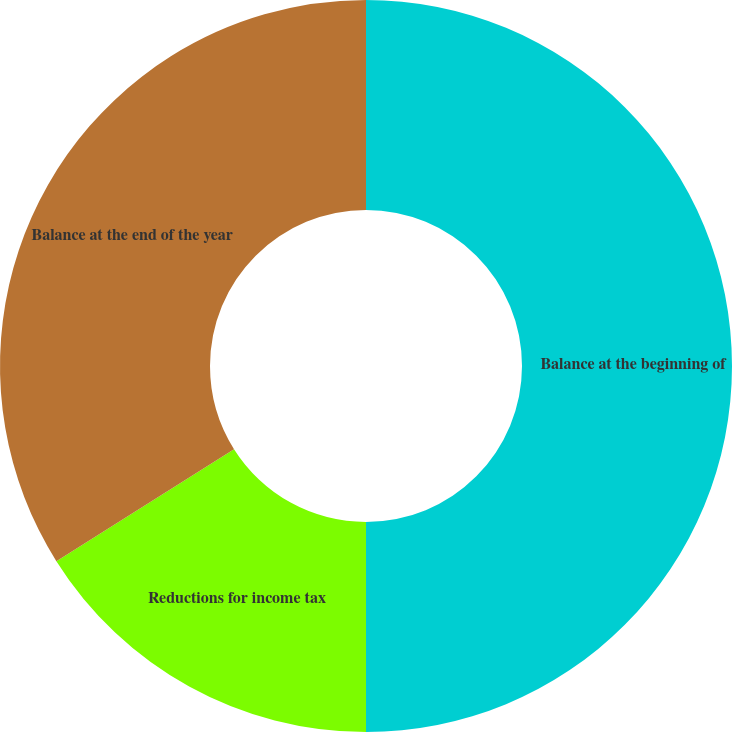Convert chart to OTSL. <chart><loc_0><loc_0><loc_500><loc_500><pie_chart><fcel>Balance at the beginning of<fcel>Reductions for income tax<fcel>Balance at the end of the year<nl><fcel>50.0%<fcel>16.05%<fcel>33.95%<nl></chart> 